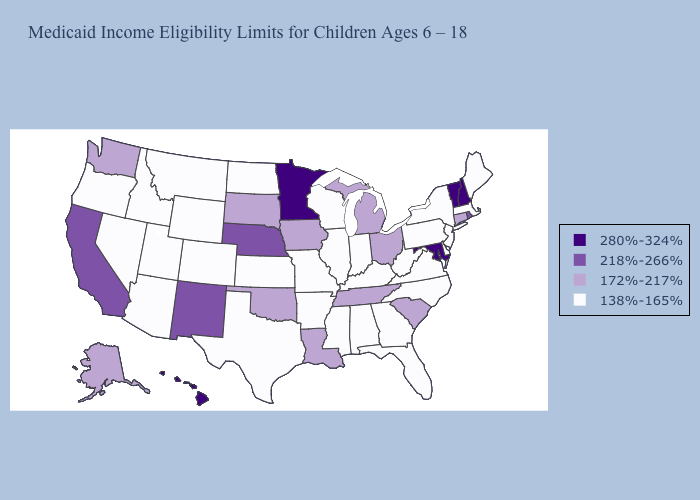Name the states that have a value in the range 218%-266%?
Give a very brief answer. California, Nebraska, New Mexico, Rhode Island. Which states hav the highest value in the MidWest?
Keep it brief. Minnesota. Does the first symbol in the legend represent the smallest category?
Write a very short answer. No. Does Arkansas have the highest value in the South?
Quick response, please. No. Among the states that border Illinois , does Iowa have the lowest value?
Keep it brief. No. Name the states that have a value in the range 138%-165%?
Keep it brief. Alabama, Arizona, Arkansas, Colorado, Delaware, Florida, Georgia, Idaho, Illinois, Indiana, Kansas, Kentucky, Maine, Massachusetts, Mississippi, Missouri, Montana, Nevada, New Jersey, New York, North Carolina, North Dakota, Oregon, Pennsylvania, Texas, Utah, Virginia, West Virginia, Wisconsin, Wyoming. Does Tennessee have a lower value than North Carolina?
Concise answer only. No. Name the states that have a value in the range 172%-217%?
Quick response, please. Alaska, Connecticut, Iowa, Louisiana, Michigan, Ohio, Oklahoma, South Carolina, South Dakota, Tennessee, Washington. Is the legend a continuous bar?
Give a very brief answer. No. Among the states that border Idaho , does Washington have the lowest value?
Answer briefly. No. What is the value of Wisconsin?
Write a very short answer. 138%-165%. Which states have the lowest value in the West?
Keep it brief. Arizona, Colorado, Idaho, Montana, Nevada, Oregon, Utah, Wyoming. Does Iowa have the lowest value in the USA?
Concise answer only. No. Does Michigan have the lowest value in the MidWest?
Be succinct. No. Is the legend a continuous bar?
Keep it brief. No. 